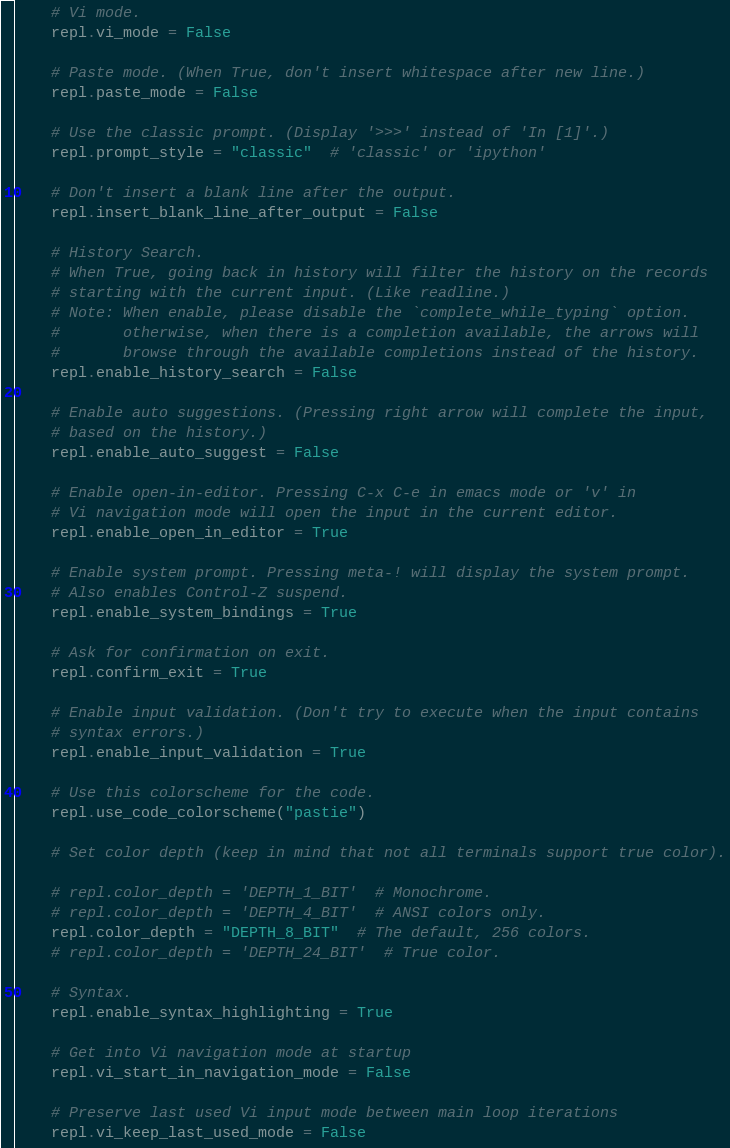Convert code to text. <code><loc_0><loc_0><loc_500><loc_500><_Python_>
    # Vi mode.
    repl.vi_mode = False

    # Paste mode. (When True, don't insert whitespace after new line.)
    repl.paste_mode = False

    # Use the classic prompt. (Display '>>>' instead of 'In [1]'.)
    repl.prompt_style = "classic"  # 'classic' or 'ipython'

    # Don't insert a blank line after the output.
    repl.insert_blank_line_after_output = False

    # History Search.
    # When True, going back in history will filter the history on the records
    # starting with the current input. (Like readline.)
    # Note: When enable, please disable the `complete_while_typing` option.
    #       otherwise, when there is a completion available, the arrows will
    #       browse through the available completions instead of the history.
    repl.enable_history_search = False

    # Enable auto suggestions. (Pressing right arrow will complete the input,
    # based on the history.)
    repl.enable_auto_suggest = False

    # Enable open-in-editor. Pressing C-x C-e in emacs mode or 'v' in
    # Vi navigation mode will open the input in the current editor.
    repl.enable_open_in_editor = True

    # Enable system prompt. Pressing meta-! will display the system prompt.
    # Also enables Control-Z suspend.
    repl.enable_system_bindings = True

    # Ask for confirmation on exit.
    repl.confirm_exit = True

    # Enable input validation. (Don't try to execute when the input contains
    # syntax errors.)
    repl.enable_input_validation = True

    # Use this colorscheme for the code.
    repl.use_code_colorscheme("pastie")

    # Set color depth (keep in mind that not all terminals support true color).

    # repl.color_depth = 'DEPTH_1_BIT'  # Monochrome.
    # repl.color_depth = 'DEPTH_4_BIT'  # ANSI colors only.
    repl.color_depth = "DEPTH_8_BIT"  # The default, 256 colors.
    # repl.color_depth = 'DEPTH_24_BIT'  # True color.

    # Syntax.
    repl.enable_syntax_highlighting = True

    # Get into Vi navigation mode at startup
    repl.vi_start_in_navigation_mode = False

    # Preserve last used Vi input mode between main loop iterations
    repl.vi_keep_last_used_mode = False
</code> 